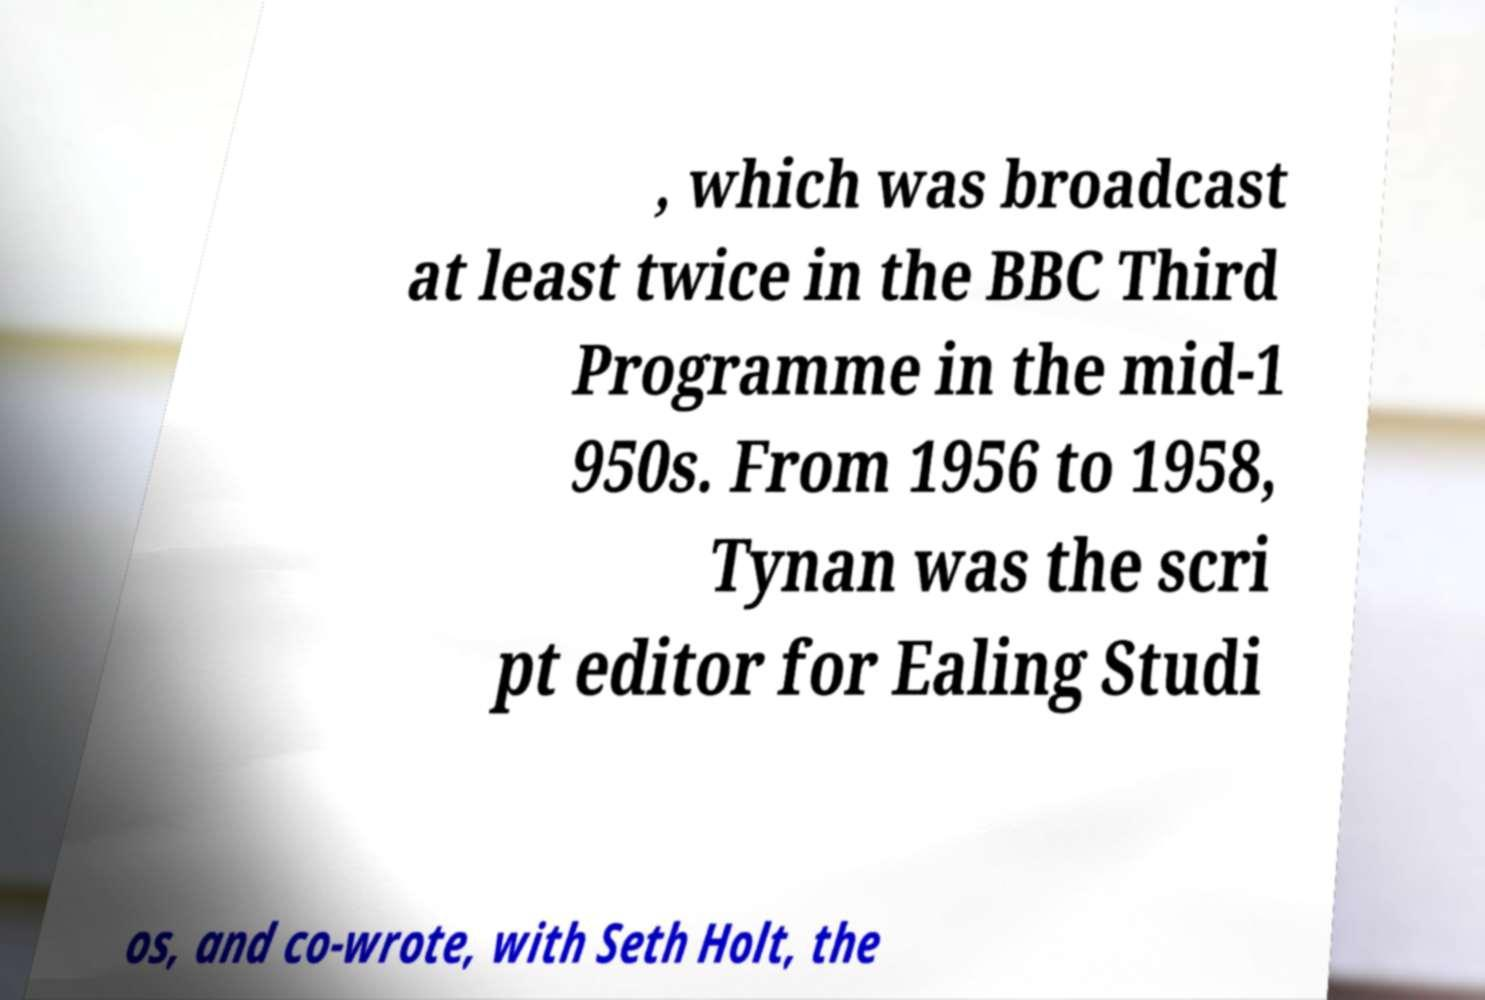Can you accurately transcribe the text from the provided image for me? , which was broadcast at least twice in the BBC Third Programme in the mid-1 950s. From 1956 to 1958, Tynan was the scri pt editor for Ealing Studi os, and co-wrote, with Seth Holt, the 